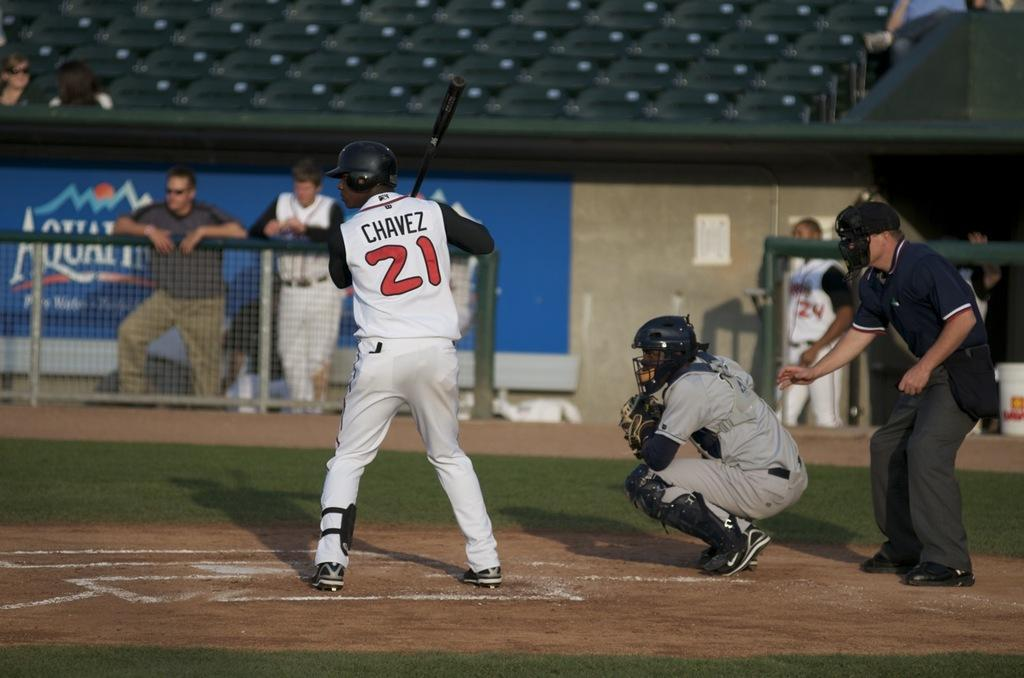<image>
Provide a brief description of the given image. A baseball player named Chavez is up to bat. 